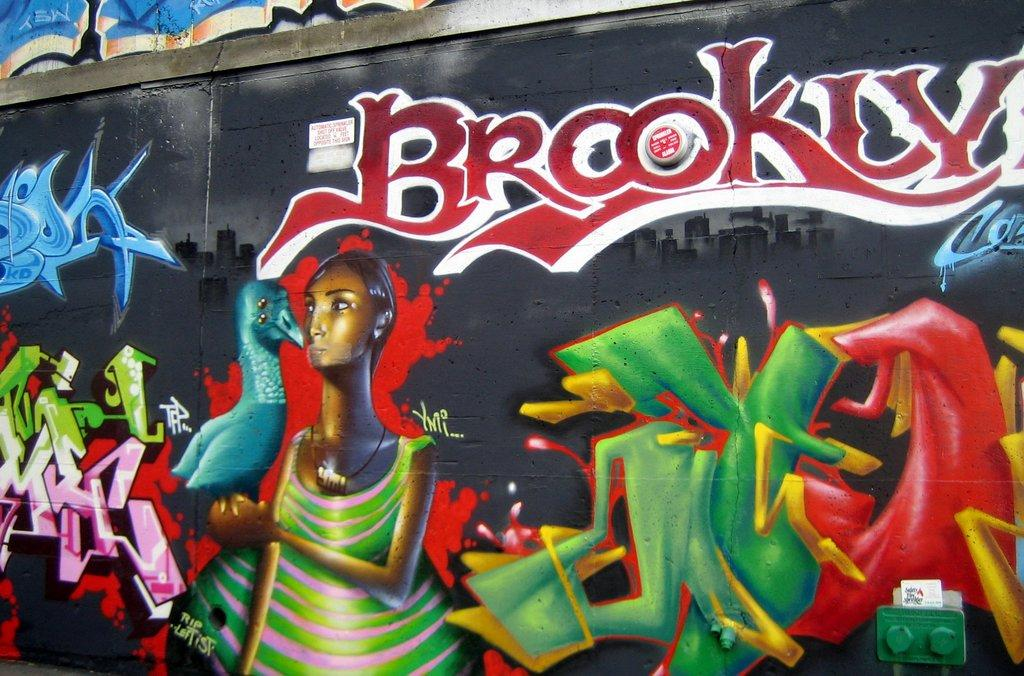What is on the wall in the image? There is graffiti on the wall in the image. What elements are included in the graffiti? The graffiti contains images and text. Is there anything else on the wall besides the graffiti? Yes, there is an object on the wall in the image. Can you see any berries growing on the wall in the image? No, there are no berries present in the image. Is there a lake visible in the background of the image? No, there is no lake visible in the image; it only features a wall with graffiti and an object. 